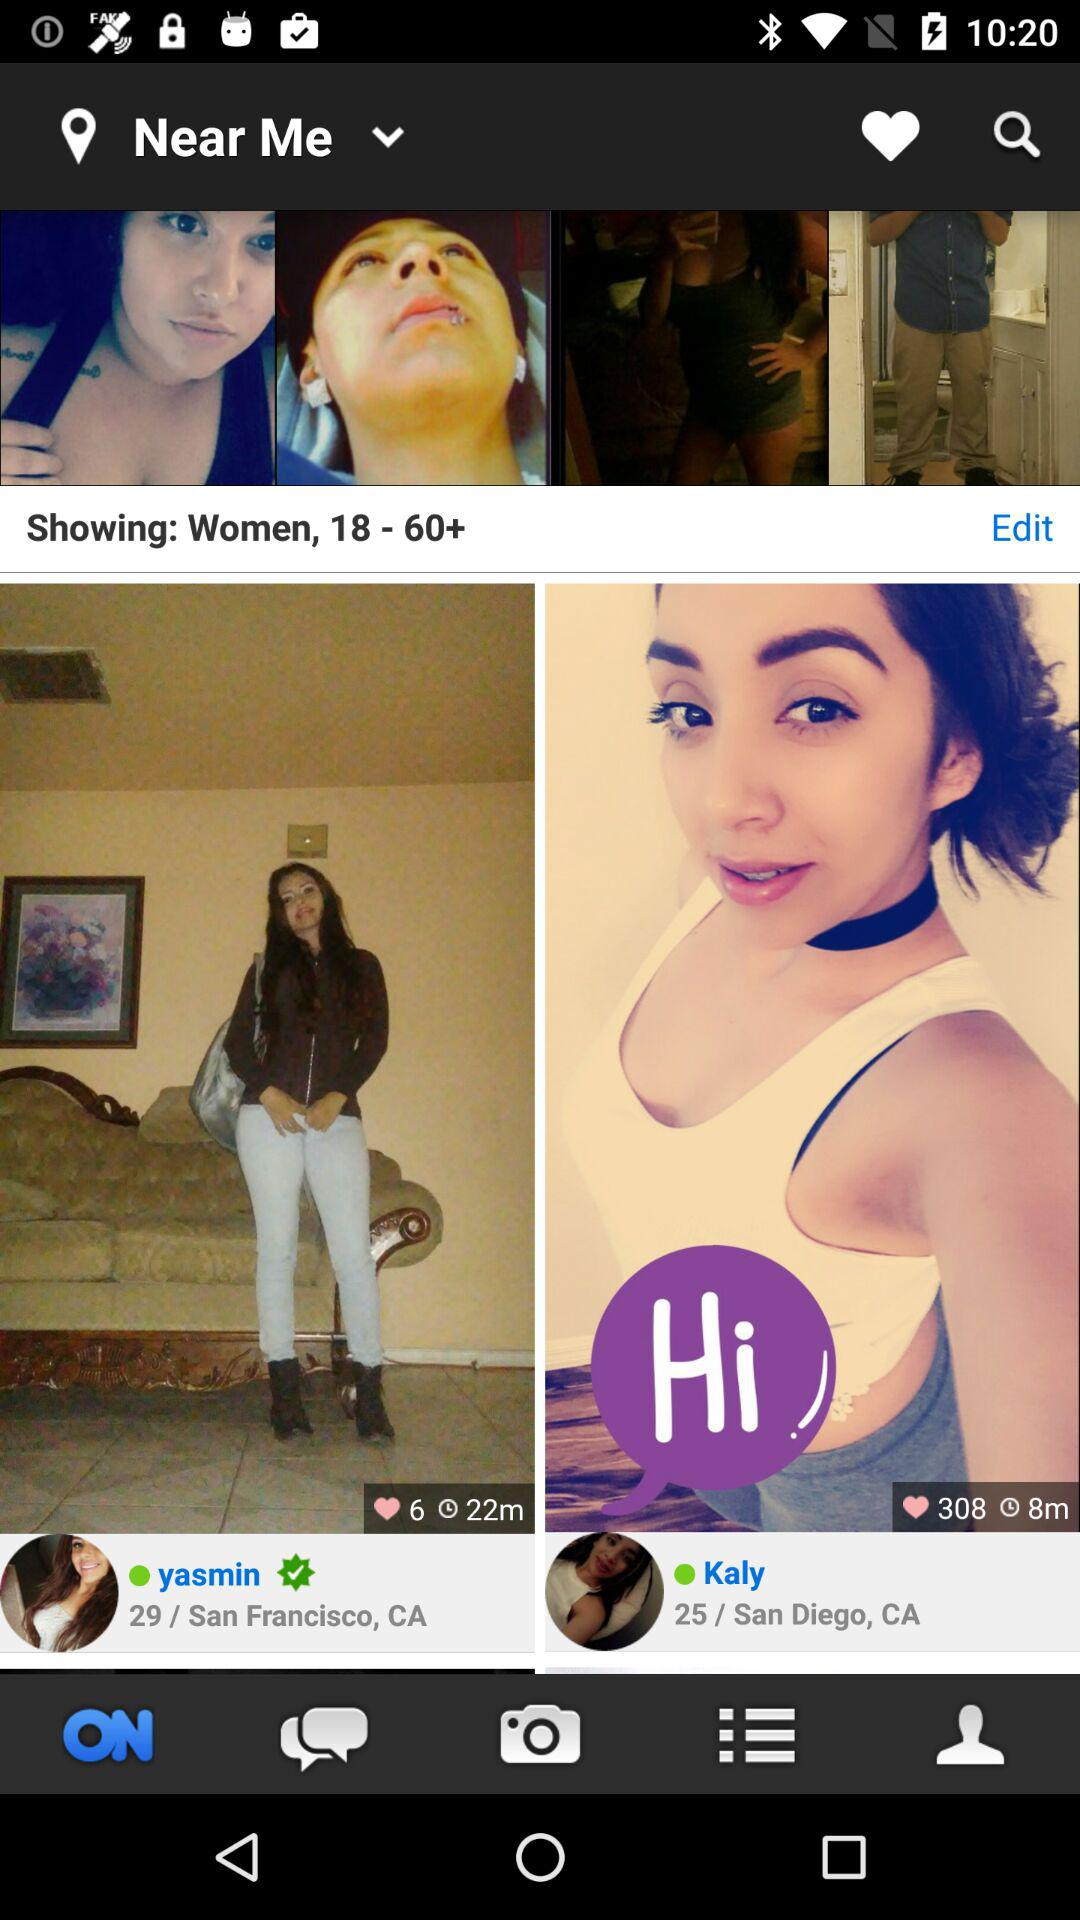How many likes are there on Kaly's photo? There are 308 likes. 